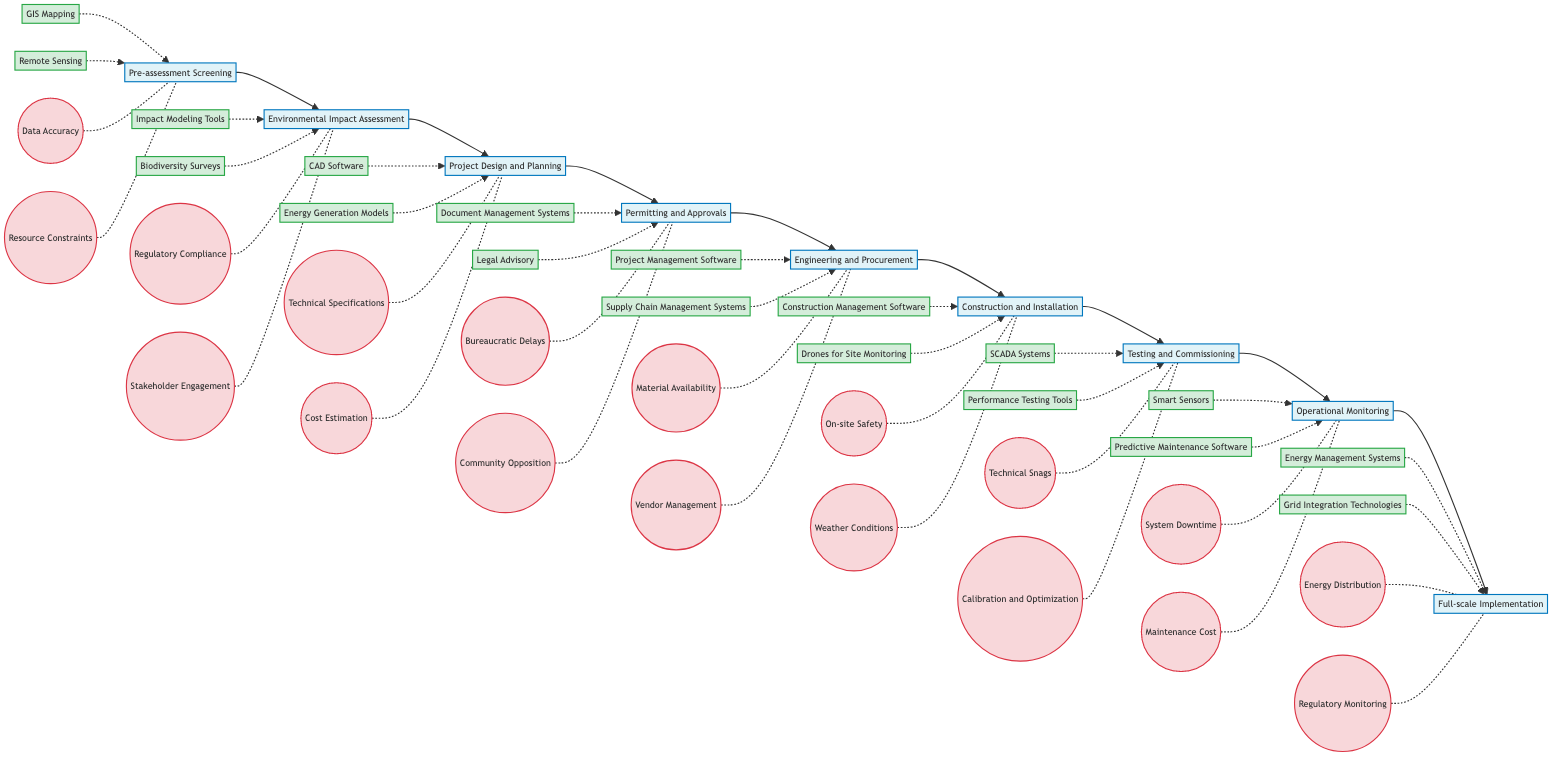What is the first step in the renewable energy generation process? The diagram shows "Pre-assessment Screening" as the first step, indicated on the leftmost position.
Answer: Pre-assessment Screening How many key technologies are associated with "Environmental Impact Assessment"? The diagram lists two key technologies linked to this step: "Impact Modeling Tools" and "Biodiversity Surveys," which can be counted visually.
Answer: 2 What is the main challenge during the "Permitting and Approvals" step? Reviewing the challenges listed under "Permitting and Approvals," the notable challenge that stands out is "Bureaucratic Delays," which is highlighted under the corresponding node.
Answer: Bureaucratic Delays Which technologies are used in the "Construction and Installation" phase? According to the diagram, two technologies are directly listed under "Construction and Installation": "Construction Management Software" and "Drones for Site Monitoring."
Answer: Construction Management Software, Drones for Site Monitoring Identify the last step before "Full-scale Implementation." The flowchart connects "Operational Monitoring" as the immediate step preceding "Full-scale Implementation," following a linear sequence to the right.
Answer: Operational Monitoring What are the two key technologies identified in the "Operational Monitoring" step? The diagram specifies "Smart Sensors" and "Predictive Maintenance Software" as the key technologies for this step, depicting them just underneath the node for "Operational Monitoring."
Answer: Smart Sensors, Predictive Maintenance Software Which phase in the diagram involves securing permits? The step that involves obtaining necessary permits is labeled "Permitting and Approvals," which is explicitly mentioned in the flowchart.
Answer: Permitting and Approvals How many total steps are outlined in the renewables implementation process from start to finish? By examining the diagram, there are nine clearly identified steps from "Pre-assessment Screening" to "Full-scale Implementation."
Answer: 9 Are "Technical Specifications" and "Cost Estimation" challenges or technologies? The flowchart categorizes "Technical Specifications" and "Cost Estimation" under challenges, as indicated by their placement and formatting in the diagram.
Answer: Challenges 